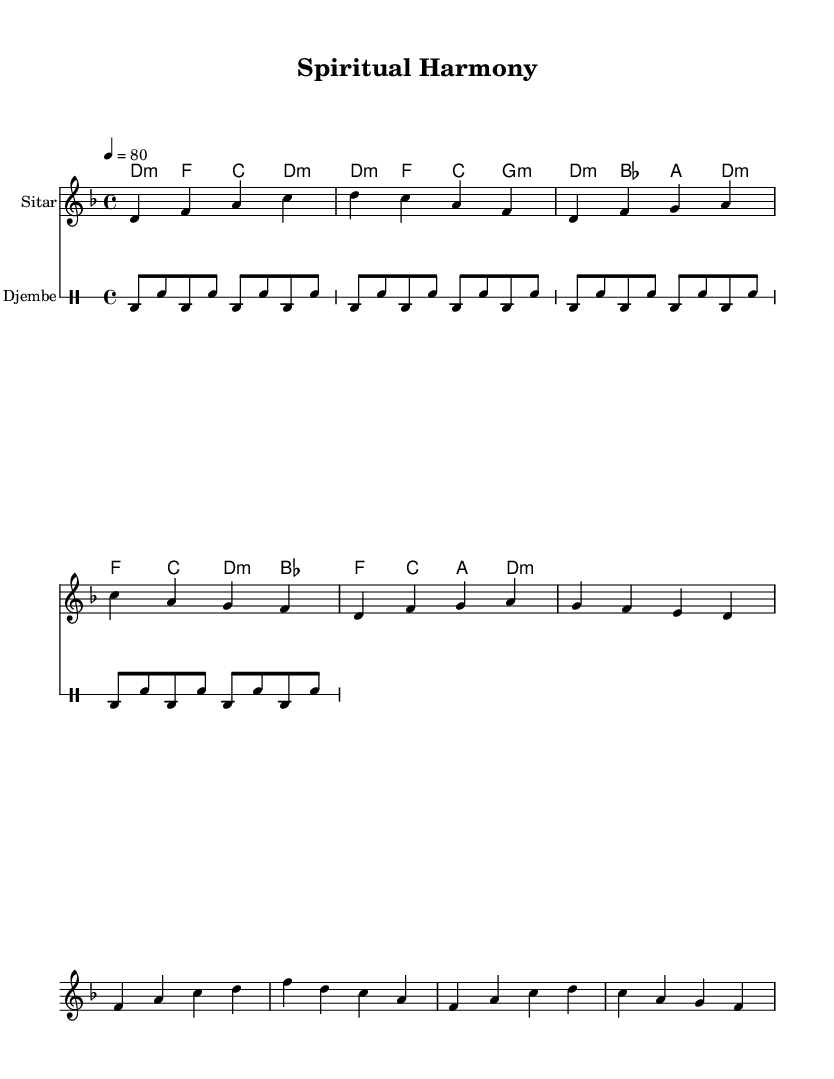What is the key signature of this music? The key signature is D minor, indicated by the presence of one flat (B flat).
Answer: D minor What is the time signature of the piece? The time signature is 4/4, which means there are four beats in a measure and the quarter note gets one beat.
Answer: 4/4 What is the tempo marking for the piece? The tempo marking is 80 beats per minute, as indicated in the tempo directive at the beginning of the score.
Answer: 80 How many sections are there in the melody? The melody has three distinct sections: Intro, Verse, and Chorus, each contributing to the structure of the piece.
Answer: Three What instrument plays the melody in this score? The melody is played on the Sitar, as designated by the instrument name in the staff.
Answer: Sitar What is the primary theme of the lyrics? The primary theme of the lyrics is peace, as evidenced by the phrase "Om, Peace be with you."
Answer: Peace 